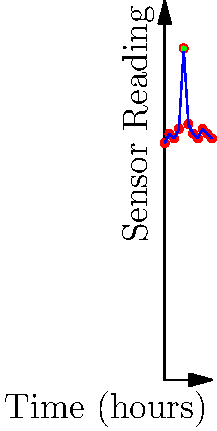Based on the sensor readings displayed on the control panel over a 10-hour period, at which hour does an anomaly in the water purification system likely occur? To identify the anomaly in the sensor readings, we need to follow these steps:

1. Analyze the overall trend: The sensor readings generally fluctuate between 50 and 54 units throughout the 10-hour period.

2. Look for outliers: There is a significant spike in the reading at hour 4, reaching 70 units.

3. Compare the outlier to normal range: The reading at hour 4 (70 units) is substantially higher than the typical range (50-54 units).

4. Consider the context: As a water treatment plant manager, you know that sudden spikes in sensor readings could indicate issues in the purification system, such as equipment malfunction or contamination.

5. Evaluate recovery: The readings return to the normal range immediately after the spike, suggesting a temporary anomaly rather than a persistent issue.

6. Conclusion: The anomaly occurs at hour 4, as indicated by the sudden spike to 70 units, which is significantly outside the normal range of sensor readings.

This anomaly warrants immediate investigation to ensure the water purification system is functioning correctly and to prevent any potential issues with water quality.
Answer: Hour 4 